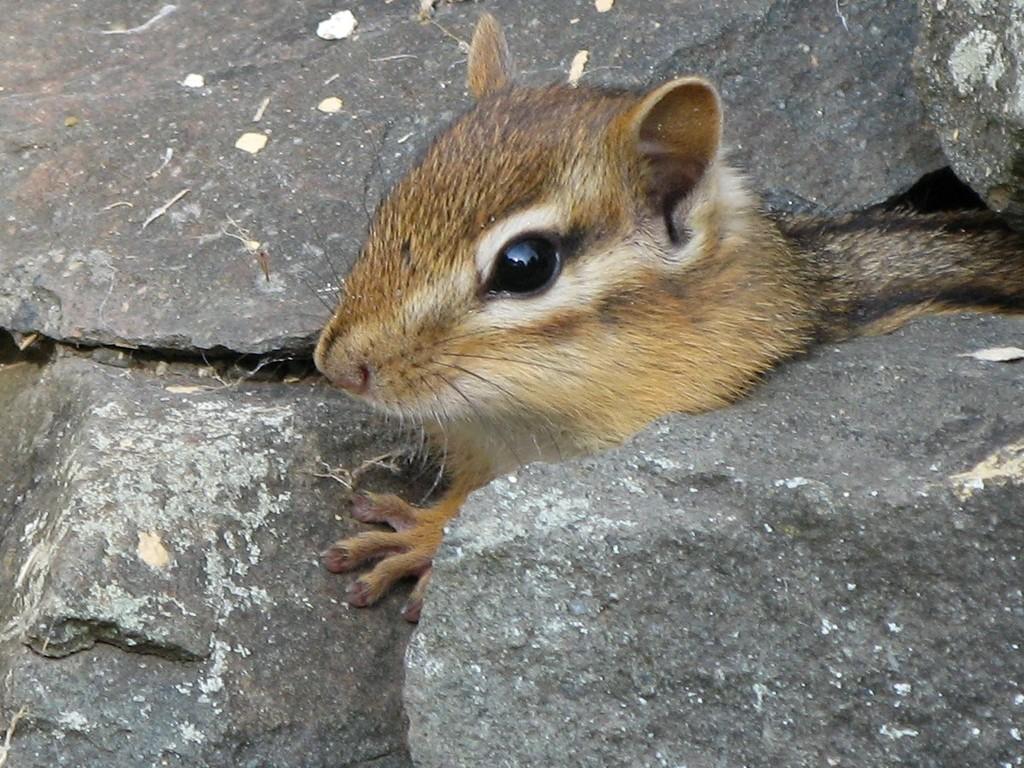Describe this image in one or two sentences. In the image we can see a chipmunk, light brown, white and black in color. These are the stones. 